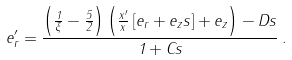<formula> <loc_0><loc_0><loc_500><loc_500>e _ { r } ^ { \prime } = \frac { \left ( \frac { 1 } { \xi } - \frac { 5 } { 2 } \right ) \left ( \frac { x ^ { \prime } } { x } \left [ e _ { r } + e _ { z } s \right ] + e _ { z } \right ) - D s } { 1 + C s } \, .</formula> 